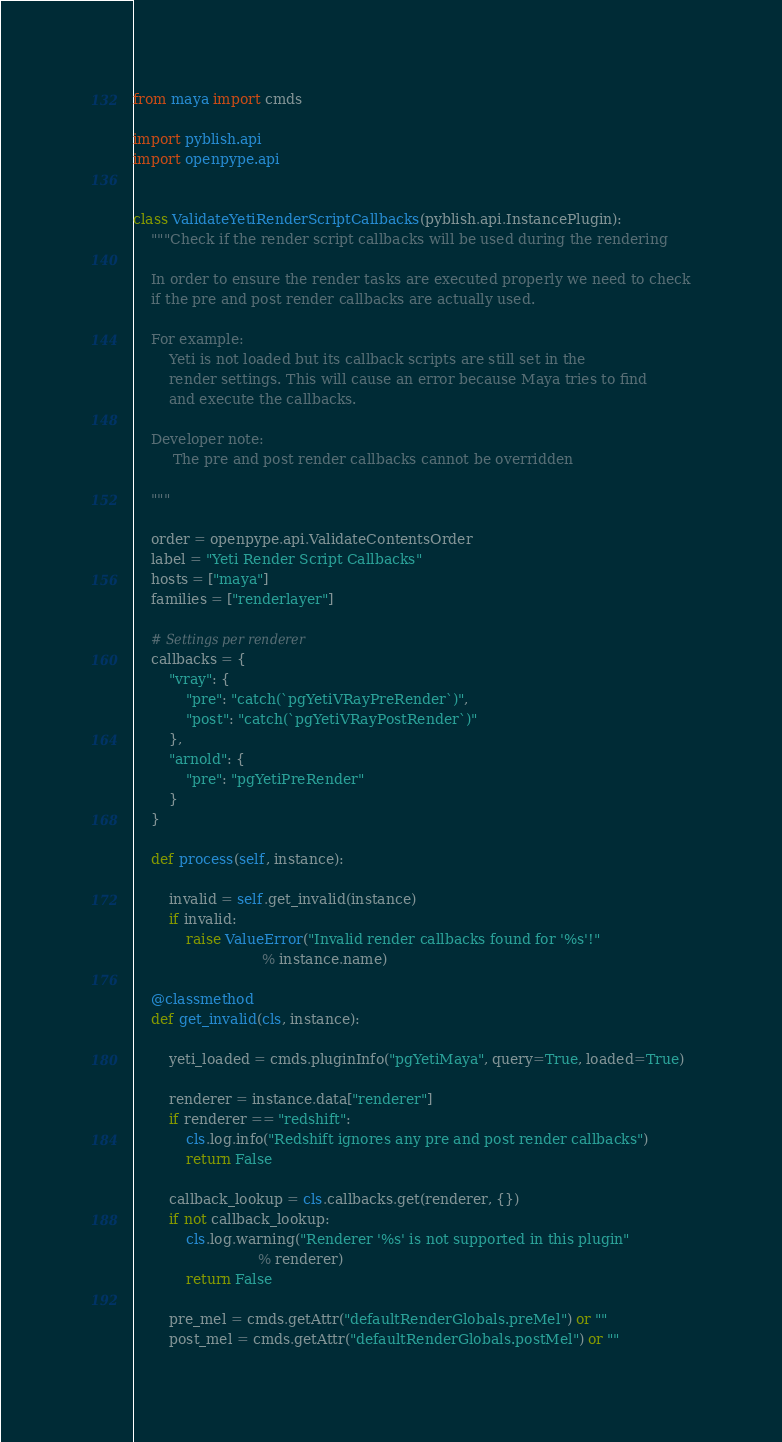<code> <loc_0><loc_0><loc_500><loc_500><_Python_>from maya import cmds

import pyblish.api
import openpype.api


class ValidateYetiRenderScriptCallbacks(pyblish.api.InstancePlugin):
    """Check if the render script callbacks will be used during the rendering

    In order to ensure the render tasks are executed properly we need to check
    if the pre and post render callbacks are actually used.

    For example:
        Yeti is not loaded but its callback scripts are still set in the
        render settings. This will cause an error because Maya tries to find
        and execute the callbacks.

    Developer note:
         The pre and post render callbacks cannot be overridden

    """

    order = openpype.api.ValidateContentsOrder
    label = "Yeti Render Script Callbacks"
    hosts = ["maya"]
    families = ["renderlayer"]

    # Settings per renderer
    callbacks = {
        "vray": {
            "pre": "catch(`pgYetiVRayPreRender`)",
            "post": "catch(`pgYetiVRayPostRender`)"
        },
        "arnold": {
            "pre": "pgYetiPreRender"
        }
    }

    def process(self, instance):

        invalid = self.get_invalid(instance)
        if invalid:
            raise ValueError("Invalid render callbacks found for '%s'!"
                             % instance.name)

    @classmethod
    def get_invalid(cls, instance):

        yeti_loaded = cmds.pluginInfo("pgYetiMaya", query=True, loaded=True)

        renderer = instance.data["renderer"]
        if renderer == "redshift":
            cls.log.info("Redshift ignores any pre and post render callbacks")
            return False

        callback_lookup = cls.callbacks.get(renderer, {})
        if not callback_lookup:
            cls.log.warning("Renderer '%s' is not supported in this plugin"
                            % renderer)
            return False

        pre_mel = cmds.getAttr("defaultRenderGlobals.preMel") or ""
        post_mel = cmds.getAttr("defaultRenderGlobals.postMel") or ""
</code> 